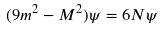<formula> <loc_0><loc_0><loc_500><loc_500>( 9 m ^ { 2 } - M ^ { 2 } ) \psi = 6 N \psi</formula> 